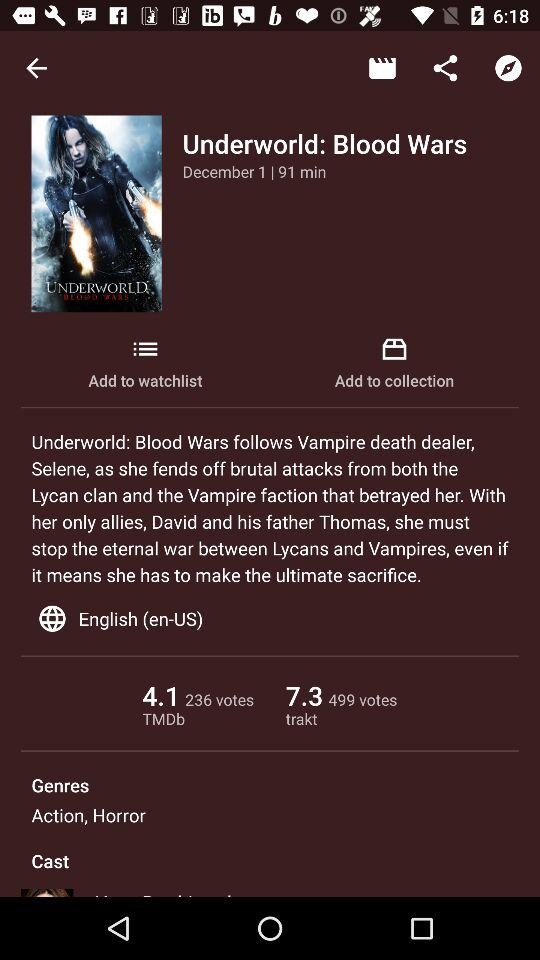What is the released date? The released date is December 1. 